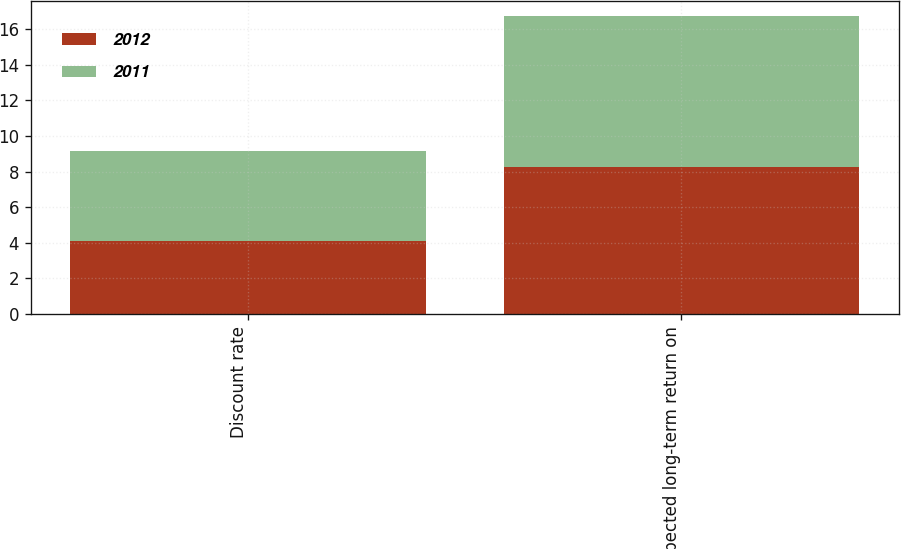Convert chart. <chart><loc_0><loc_0><loc_500><loc_500><stacked_bar_chart><ecel><fcel>Discount rate<fcel>Expected long-term return on<nl><fcel>2012<fcel>4.12<fcel>8.25<nl><fcel>2011<fcel>5.03<fcel>8.5<nl></chart> 